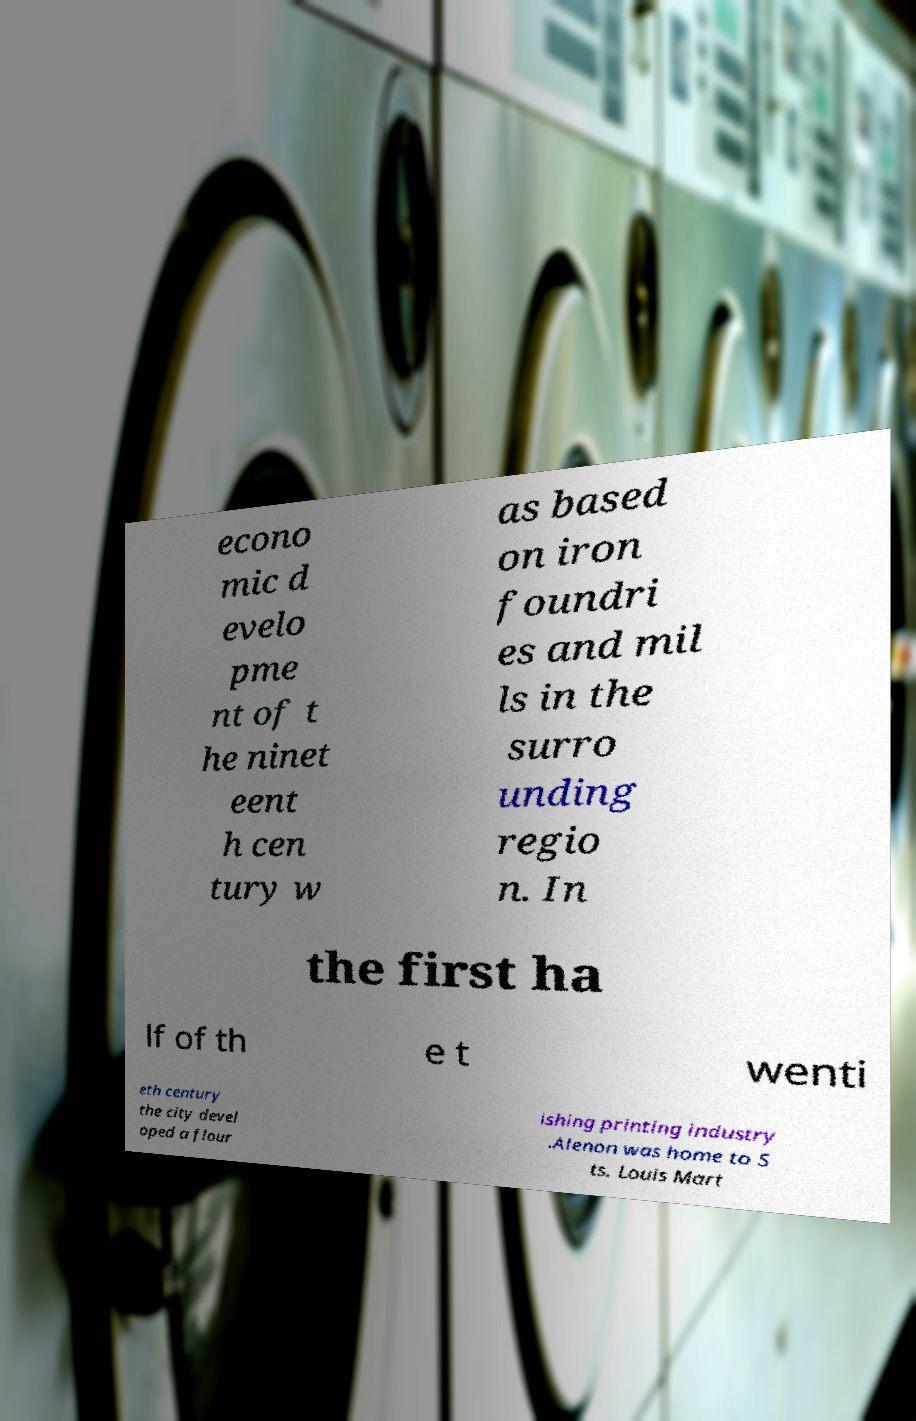Could you assist in decoding the text presented in this image and type it out clearly? econo mic d evelo pme nt of t he ninet eent h cen tury w as based on iron foundri es and mil ls in the surro unding regio n. In the first ha lf of th e t wenti eth century the city devel oped a flour ishing printing industry .Alenon was home to S ts. Louis Mart 